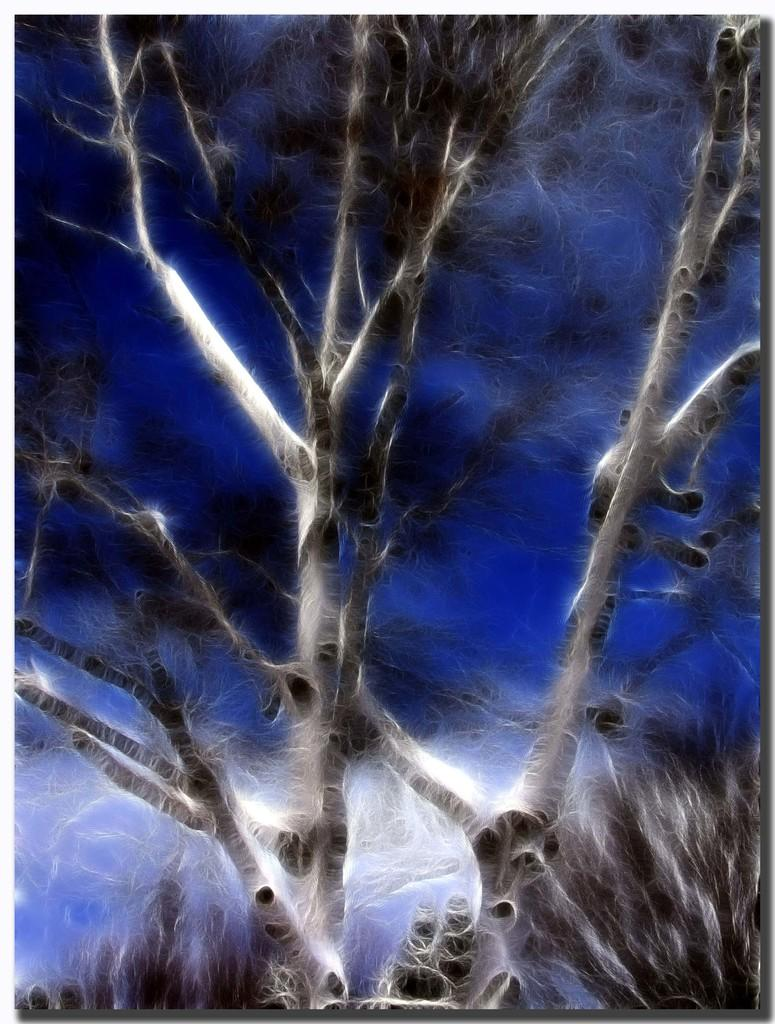What type of trees are depicted in the image? The trees in the image are animated. What color is the background of the image? The background of the image is blue. What railway is visible in the image? There is no railway present in the image; it features animated trees and a blue background. What base is supporting the animated trees in the image? The animated trees do not require a base for support, as they are not real trees. 